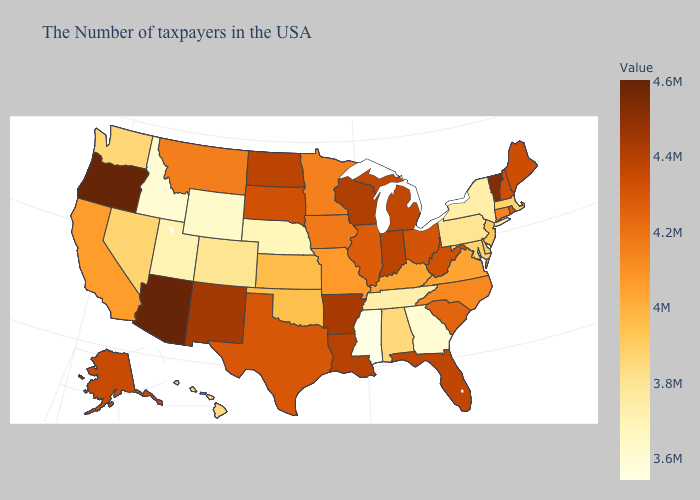Does Nevada have the highest value in the USA?
Answer briefly. No. Does Arkansas have the highest value in the South?
Concise answer only. Yes. Does South Carolina have the lowest value in the South?
Give a very brief answer. No. 